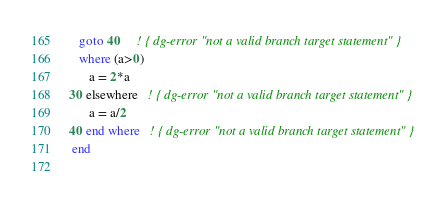Convert code to text. <code><loc_0><loc_0><loc_500><loc_500><_FORTRAN_>   goto 40     ! { dg-error "not a valid branch target statement" }
   where (a>0)
      a = 2*a
30 elsewhere   ! { dg-error "not a valid branch target statement" }
      a = a/2
40 end where   ! { dg-error "not a valid branch target statement" }
 end
 
</code> 